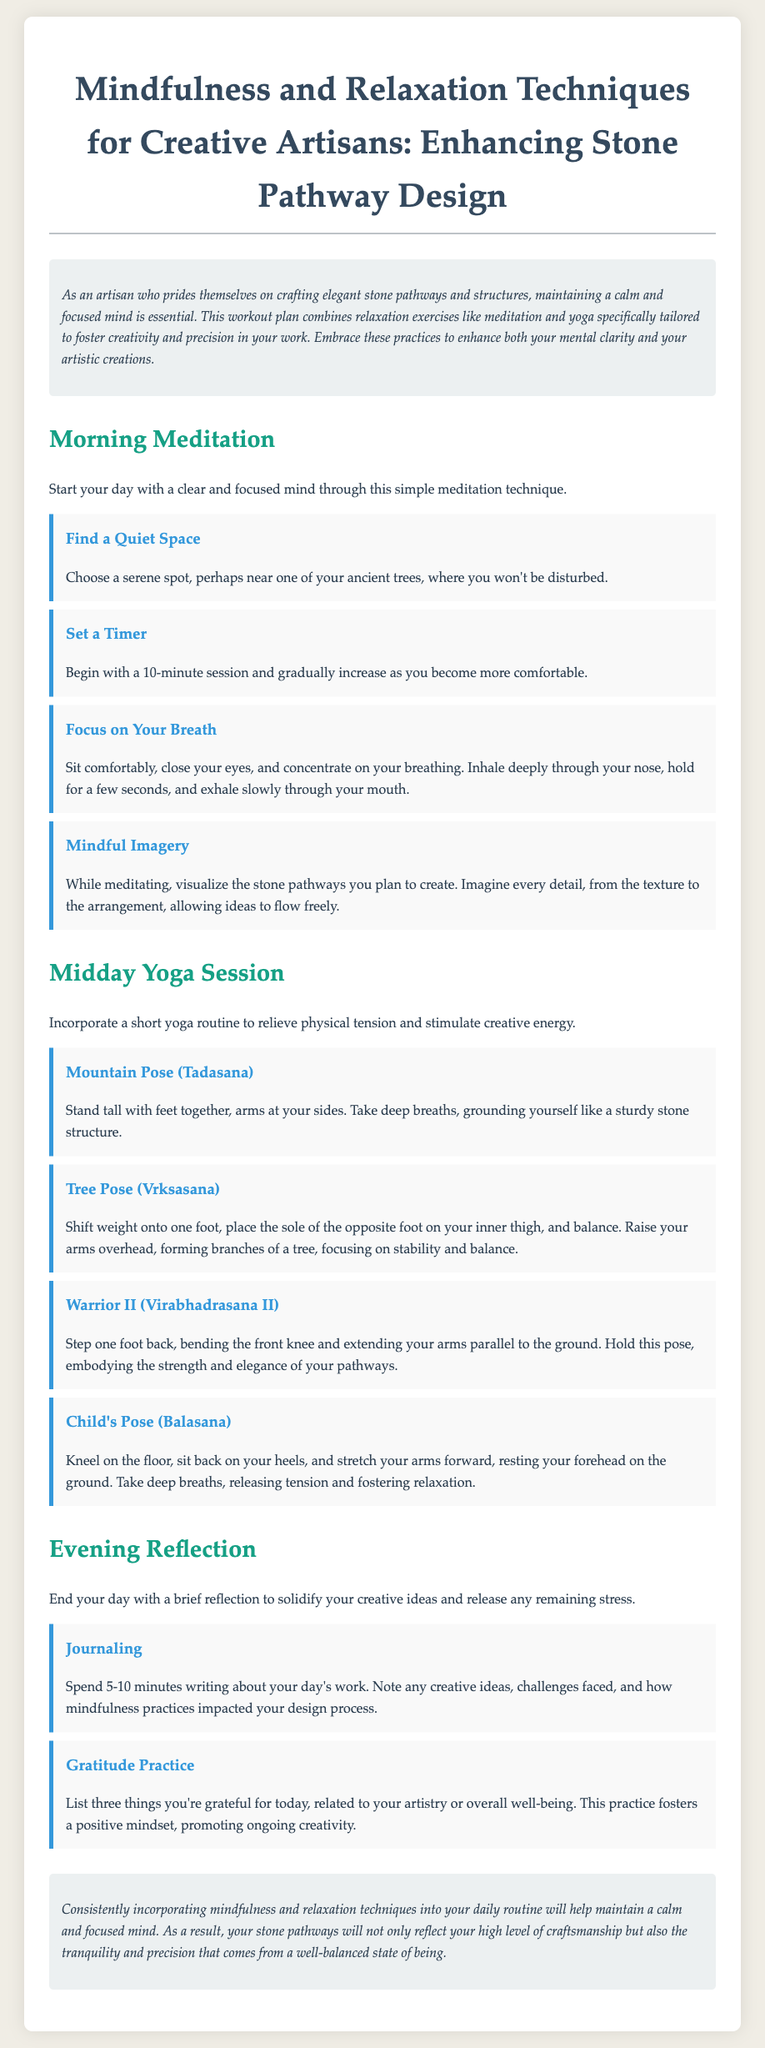what is the title of the document? The title of the document is provided in the <title> tag, which is "Mindfulness for Stone Artisans".
Answer: Mindfulness for Stone Artisans how long should the morning meditation session start at? The document states to begin with a 10-minute session for the morning meditation.
Answer: 10 minutes what pose is recommended for relieving physical tension during the midday yoga session? The document lists several yoga poses, and one of them mentioned for relieving physical tension is "Child's Pose".
Answer: Child's Pose what is one activity suggested for evening reflection? The document suggests "Journaling" as an activity for evening reflection.
Answer: Journaling what does the gratitude practice involve? The document explains that the gratitude practice involves listing three things you're grateful for related to artistry or well-being.
Answer: Listing three things what is the purpose of mindful imagery during meditation? The document indicates that the purpose of mindful imagery is to visualize the stone pathways you plan to create, allowing ideas to flow freely.
Answer: Visualize stone pathways which yoga pose emphasizes stability and balance? The document states that "Tree Pose" emphasizes stability and balance during the midday yoga session.
Answer: Tree Pose 